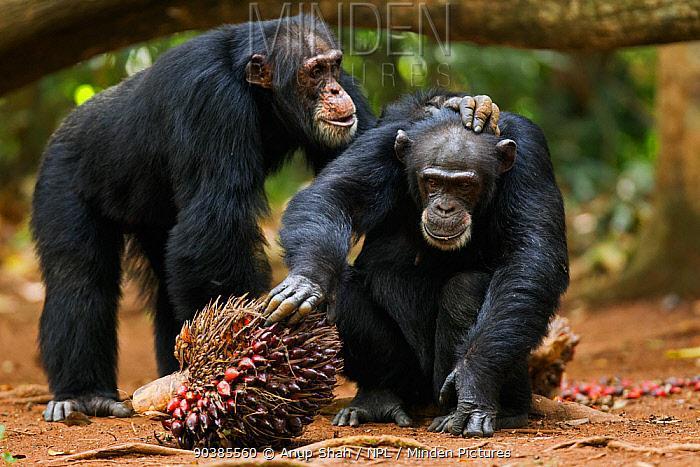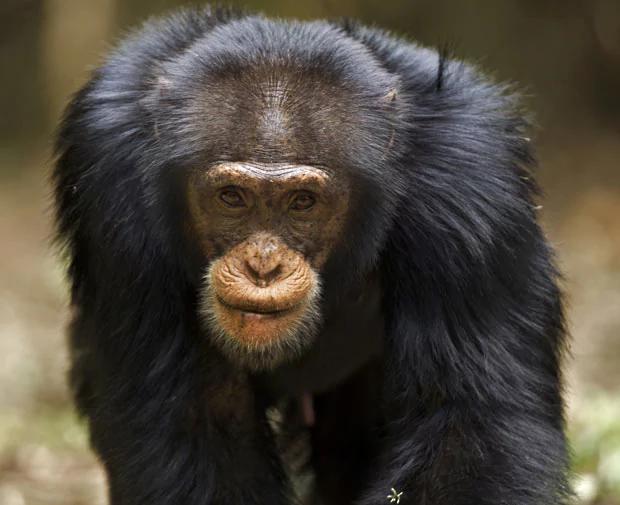The first image is the image on the left, the second image is the image on the right. Given the left and right images, does the statement "One image includes exactly twice as many chimps as the other image." hold true? Answer yes or no. Yes. The first image is the image on the left, the second image is the image on the right. Analyze the images presented: Is the assertion "The right image contains exactly one chimpanzee." valid? Answer yes or no. Yes. 